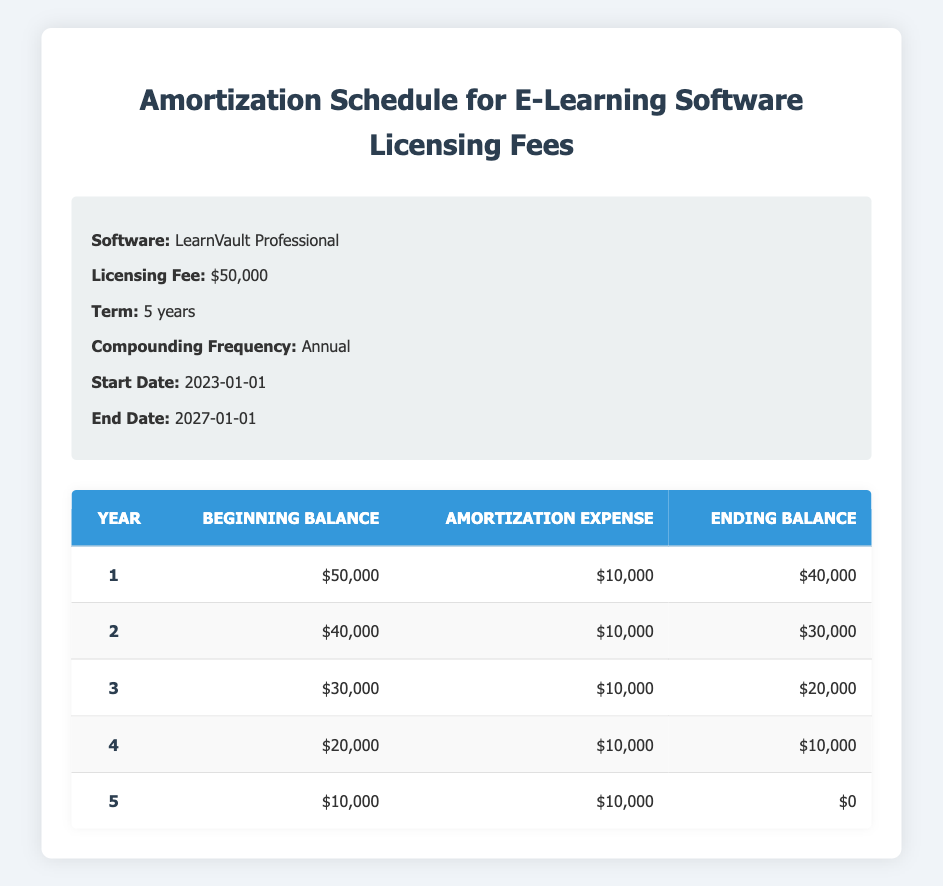What is the amortization expense for Year 3? The amortization expense for Year 3 can be found in the row corresponding to Year 3 in the table, which shows that it is 10,000.
Answer: 10,000 What is the beginning balance for Year 4? The beginning balance for Year 4 is found in the table under the column "Beginning Balance" for Year 4, which is 20,000.
Answer: 20,000 Is the ending balance for Year 5 zero? Looking at the table, the ending balance for Year 5 is listed as 0, confirming that the statement is true.
Answer: Yes What is the total amortization expense over the 5-year term? To find the total amortization expense, add the individual expenses from each year: 10,000 (Year 1) + 10,000 (Year 2) + 10,000 (Year 3) + 10,000 (Year 4) + 10,000 (Year 5) = 50,000.
Answer: 50,000 What is the average beginning balance over the 5-year term? The beginning balances are 50,000 (Year 1), 40,000 (Year 2), 30,000 (Year 3), 20,000 (Year 4), and 10,000 (Year 5). Adding them gives 50,000 + 40,000 + 30,000 + 20,000 + 10,000 = 150,000. Dividing by 5 gives the average beginning balance of 30,000.
Answer: 30,000 What is the difference between the beginning balance of Year 1 and the ending balance of Year 5? The beginning balance for Year 1 is 50,000, and the ending balance for Year 5 is 0. The difference is calculated as 50,000 - 0 = 50,000.
Answer: 50,000 Does the amortization expense remain constant throughout the term? By looking at the table, the amortization expense for each year is consistently 10,000, confirming that this statement is true.
Answer: Yes What is the ending balance for Year 2? The ending balance for Year 2 can be found directly in the table under the column "Ending Balance" for Year 2, which is 30,000.
Answer: 30,000 What is the total remaining balance after Year 3? The ending balance after Year 3 can be referenced directly from the table, showing the amount is 20,000.
Answer: 20,000 